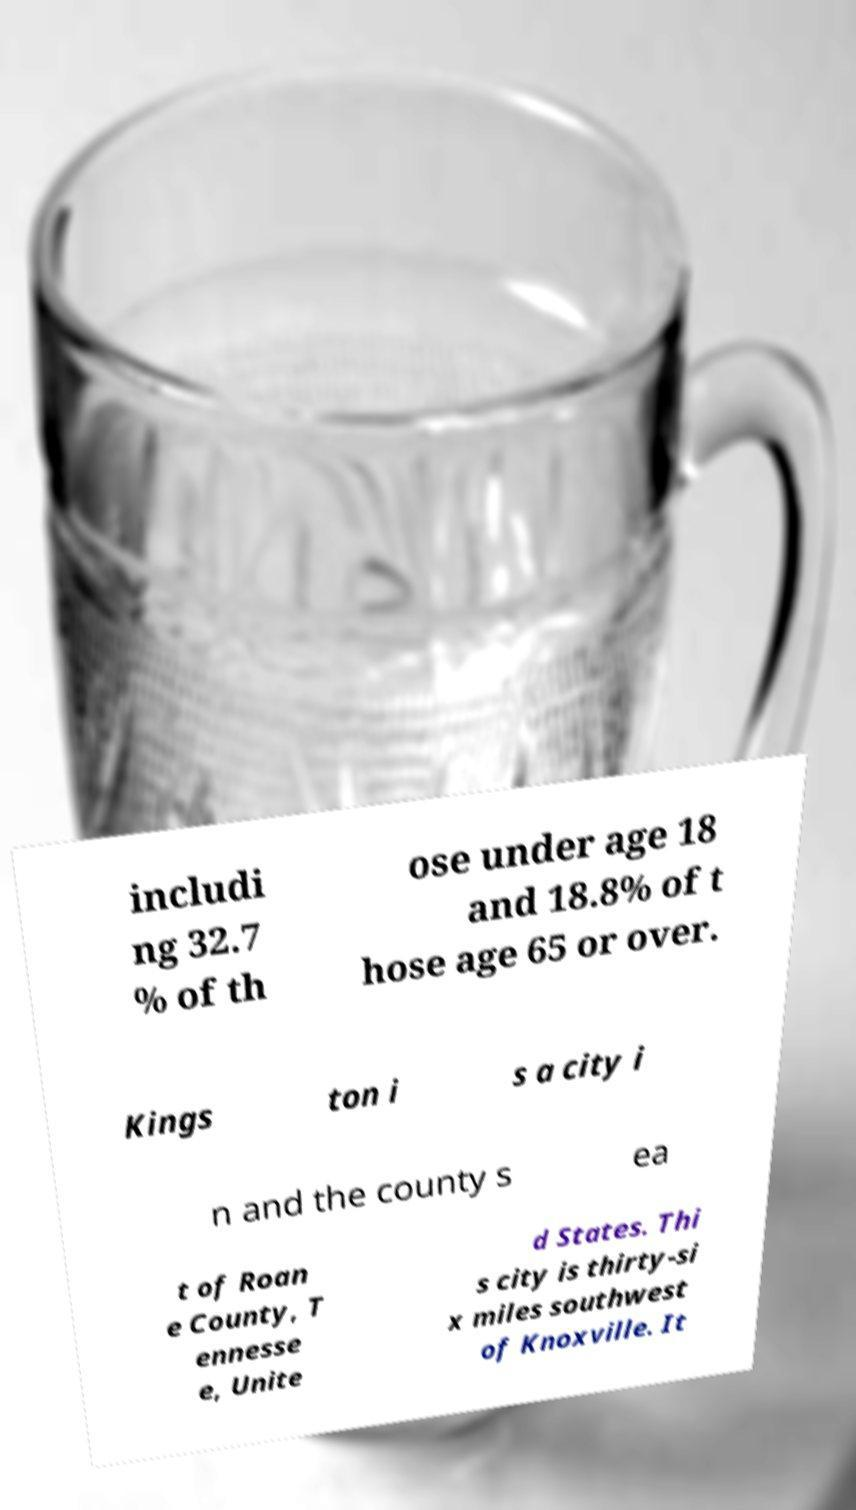What messages or text are displayed in this image? I need them in a readable, typed format. includi ng 32.7 % of th ose under age 18 and 18.8% of t hose age 65 or over. Kings ton i s a city i n and the county s ea t of Roan e County, T ennesse e, Unite d States. Thi s city is thirty-si x miles southwest of Knoxville. It 